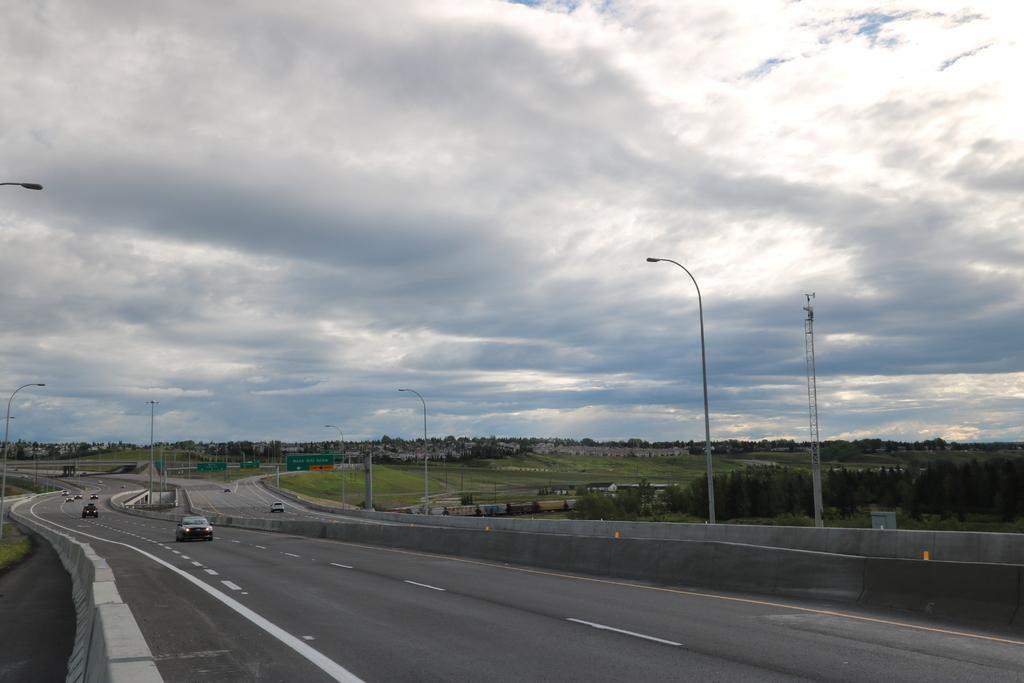Please provide a concise description of this image. There are roads. On the road there are many vehicles. On the sides of the road there are street light poles. In the background there are trees and sky with clouds. 